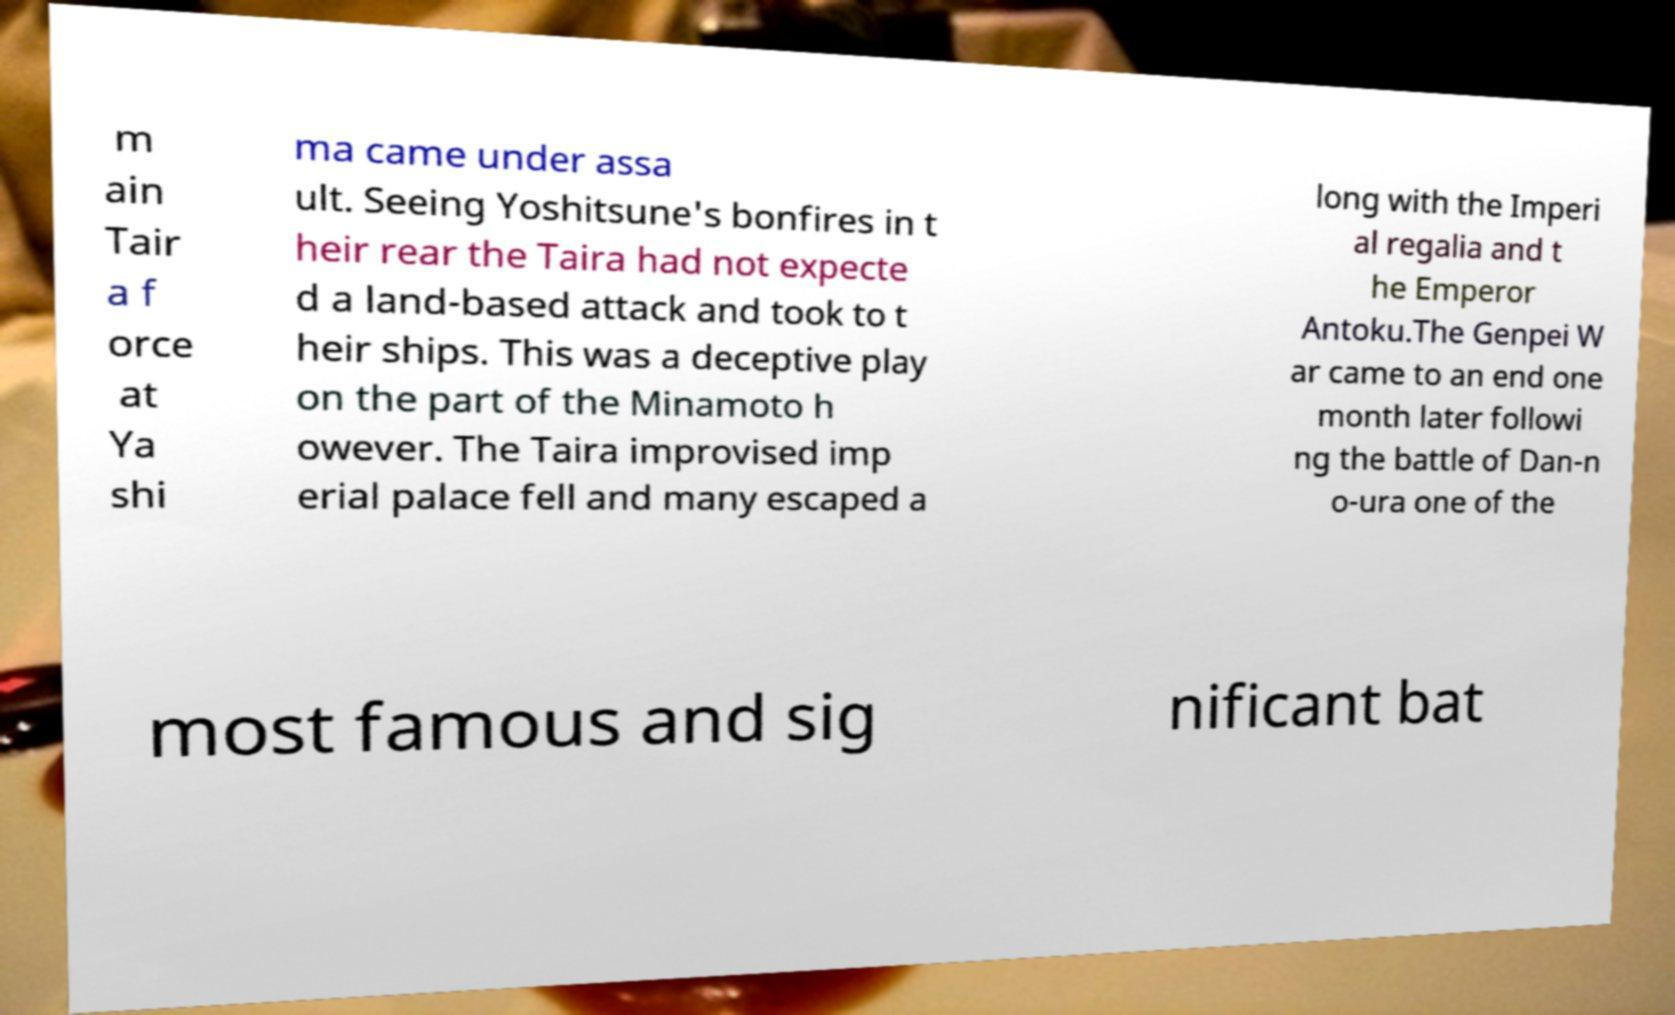There's text embedded in this image that I need extracted. Can you transcribe it verbatim? m ain Tair a f orce at Ya shi ma came under assa ult. Seeing Yoshitsune's bonfires in t heir rear the Taira had not expecte d a land-based attack and took to t heir ships. This was a deceptive play on the part of the Minamoto h owever. The Taira improvised imp erial palace fell and many escaped a long with the Imperi al regalia and t he Emperor Antoku.The Genpei W ar came to an end one month later followi ng the battle of Dan-n o-ura one of the most famous and sig nificant bat 